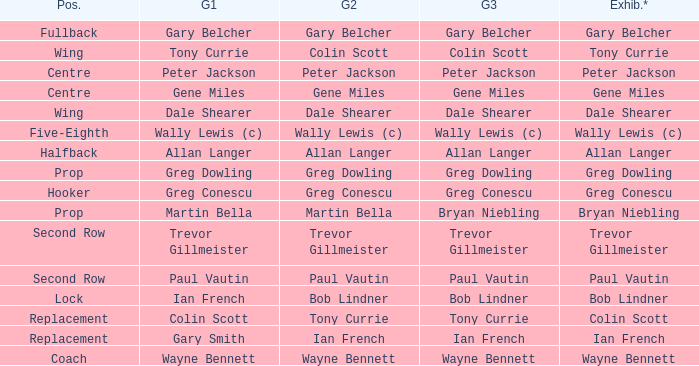What game 1 has bob lindner as game 2? Ian French. 